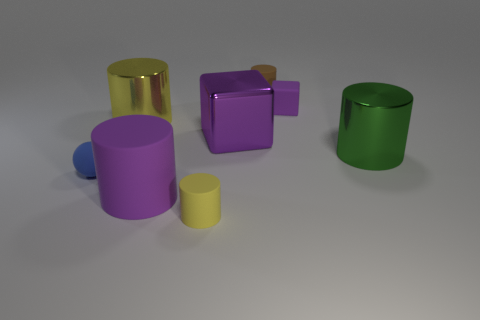Add 1 brown matte cylinders. How many objects exist? 9 Subtract all blocks. How many objects are left? 6 Subtract 1 purple cylinders. How many objects are left? 7 Subtract all tiny blue rubber spheres. Subtract all large purple objects. How many objects are left? 5 Add 8 large yellow cylinders. How many large yellow cylinders are left? 9 Add 7 blue spheres. How many blue spheres exist? 8 